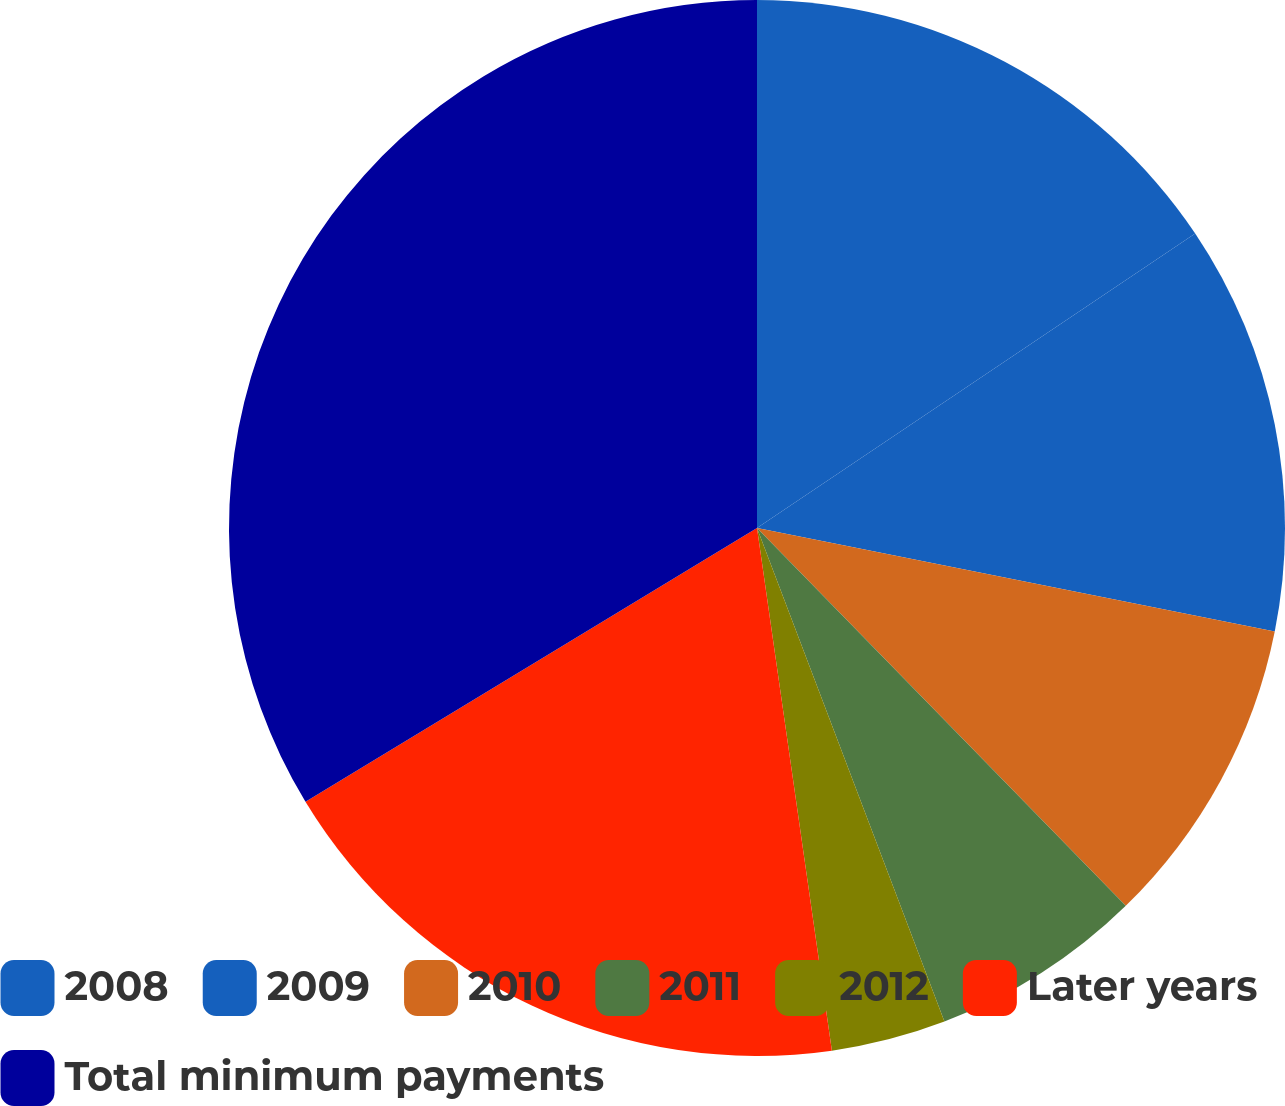Convert chart to OTSL. <chart><loc_0><loc_0><loc_500><loc_500><pie_chart><fcel>2008<fcel>2009<fcel>2010<fcel>2011<fcel>2012<fcel>Later years<fcel>Total minimum payments<nl><fcel>15.58%<fcel>12.56%<fcel>9.55%<fcel>6.53%<fcel>3.51%<fcel>18.59%<fcel>33.67%<nl></chart> 